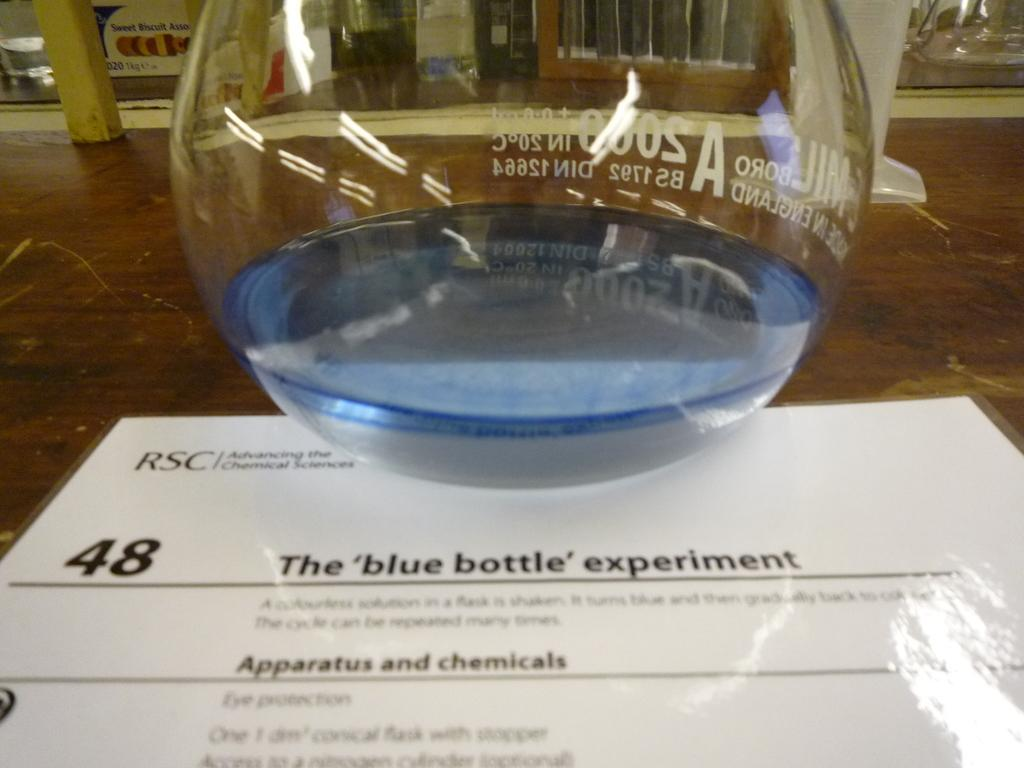What object can be seen in the image that is typically used for storage or preservation? There is a jar in the image that is typically used for storage or preservation. What other object can be seen in the image that is typically used for writing or reading? There is a paper in the image that is typically used for writing or reading. Where are the jar and paper located in the image? Both the jar and the paper are placed on a table in the image. What type of stem can be seen growing from the paper in the image? There is no stem growing from the paper in the image; it is a flat, two-dimensional object. 